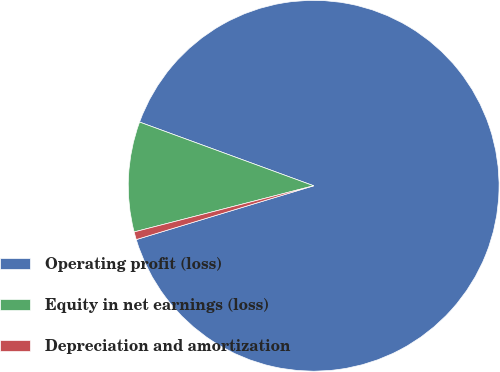<chart> <loc_0><loc_0><loc_500><loc_500><pie_chart><fcel>Operating profit (loss)<fcel>Equity in net earnings (loss)<fcel>Depreciation and amortization<nl><fcel>89.73%<fcel>9.59%<fcel>0.68%<nl></chart> 